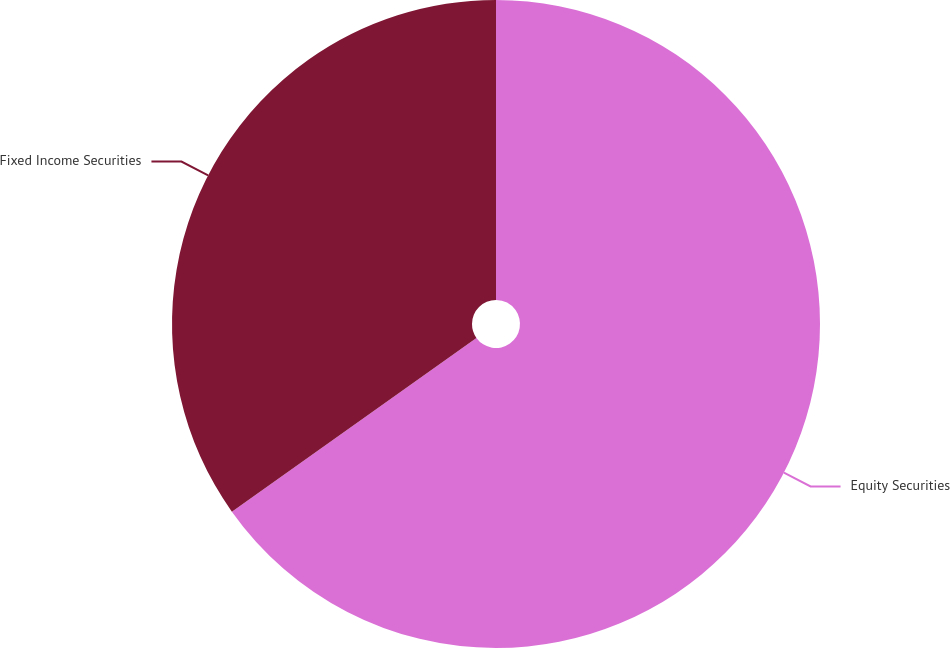Convert chart. <chart><loc_0><loc_0><loc_500><loc_500><pie_chart><fcel>Equity Securities<fcel>Fixed Income Securities<nl><fcel>65.17%<fcel>34.83%<nl></chart> 